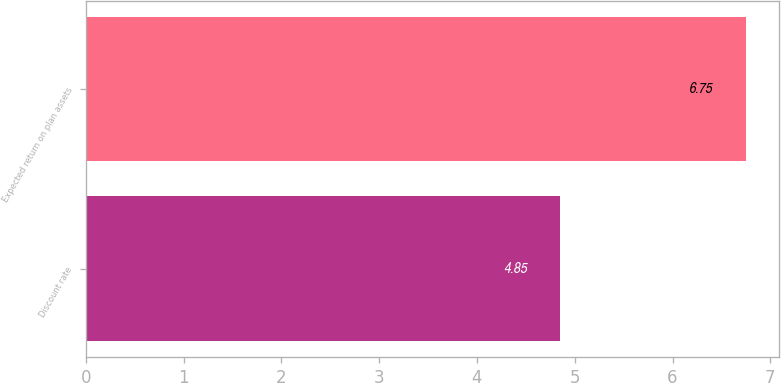Convert chart. <chart><loc_0><loc_0><loc_500><loc_500><bar_chart><fcel>Discount rate<fcel>Expected return on plan assets<nl><fcel>4.85<fcel>6.75<nl></chart> 